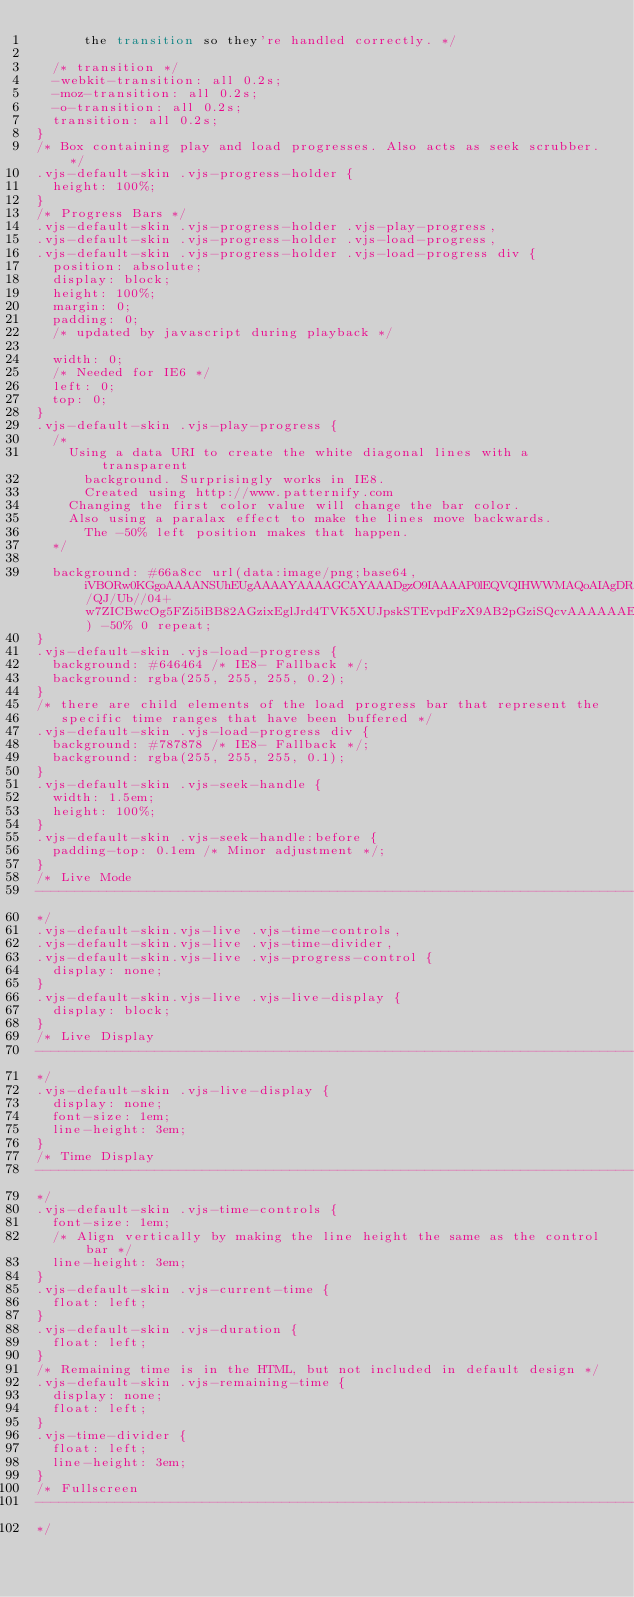Convert code to text. <code><loc_0><loc_0><loc_500><loc_500><_CSS_>      the transition so they're handled correctly. */

  /* transition */
  -webkit-transition: all 0.2s;
  -moz-transition: all 0.2s;
  -o-transition: all 0.2s;
  transition: all 0.2s;
}
/* Box containing play and load progresses. Also acts as seek scrubber. */
.vjs-default-skin .vjs-progress-holder {
  height: 100%;
}
/* Progress Bars */
.vjs-default-skin .vjs-progress-holder .vjs-play-progress,
.vjs-default-skin .vjs-progress-holder .vjs-load-progress,
.vjs-default-skin .vjs-progress-holder .vjs-load-progress div {
  position: absolute;
  display: block;
  height: 100%;
  margin: 0;
  padding: 0;
  /* updated by javascript during playback */

  width: 0;
  /* Needed for IE6 */
  left: 0;
  top: 0;
}
.vjs-default-skin .vjs-play-progress {
  /*
    Using a data URI to create the white diagonal lines with a transparent
      background. Surprisingly works in IE8.
      Created using http://www.patternify.com
    Changing the first color value will change the bar color.
    Also using a paralax effect to make the lines move backwards.
      The -50% left position makes that happen.
  */

  background: #66a8cc url(data:image/png;base64,iVBORw0KGgoAAAANSUhEUgAAAAYAAAAGCAYAAADgzO9IAAAAP0lEQVQIHWWMAQoAIAgDR/QJ/Ub//04+w7ZICBwcOg5FZi5iBB82AGzixEglJrd4TVK5XUJpskSTEvpdFzX9AB2pGziSQcvAAAAAAElFTkSuQmCC) -50% 0 repeat;
}
.vjs-default-skin .vjs-load-progress {
  background: #646464 /* IE8- Fallback */;
  background: rgba(255, 255, 255, 0.2);
}
/* there are child elements of the load progress bar that represent the
   specific time ranges that have been buffered */
.vjs-default-skin .vjs-load-progress div {
  background: #787878 /* IE8- Fallback */;
  background: rgba(255, 255, 255, 0.1);
}
.vjs-default-skin .vjs-seek-handle {
  width: 1.5em;
  height: 100%;
}
.vjs-default-skin .vjs-seek-handle:before {
  padding-top: 0.1em /* Minor adjustment */;
}
/* Live Mode
--------------------------------------------------------------------------------
*/
.vjs-default-skin.vjs-live .vjs-time-controls,
.vjs-default-skin.vjs-live .vjs-time-divider,
.vjs-default-skin.vjs-live .vjs-progress-control {
  display: none;
}
.vjs-default-skin.vjs-live .vjs-live-display {
  display: block;
}
/* Live Display
--------------------------------------------------------------------------------
*/
.vjs-default-skin .vjs-live-display {
  display: none;
  font-size: 1em;
  line-height: 3em;
}
/* Time Display
--------------------------------------------------------------------------------
*/
.vjs-default-skin .vjs-time-controls {
  font-size: 1em;
  /* Align vertically by making the line height the same as the control bar */
  line-height: 3em;
}
.vjs-default-skin .vjs-current-time {
  float: left;
}
.vjs-default-skin .vjs-duration {
  float: left;
}
/* Remaining time is in the HTML, but not included in default design */
.vjs-default-skin .vjs-remaining-time {
  display: none;
  float: left;
}
.vjs-time-divider {
  float: left;
  line-height: 3em;
}
/* Fullscreen
--------------------------------------------------------------------------------
*/</code> 